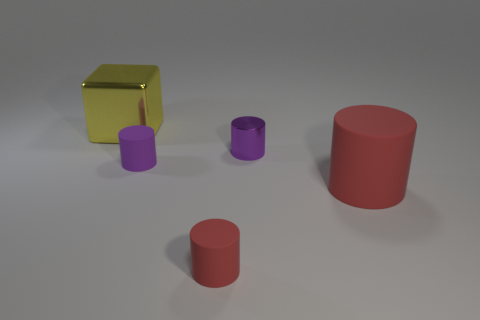Add 5 big things. How many objects exist? 10 Subtract all cylinders. How many objects are left? 1 Add 5 small metal things. How many small metal things are left? 6 Add 5 big red cylinders. How many big red cylinders exist? 6 Subtract 0 blue cubes. How many objects are left? 5 Subtract all small red shiny cylinders. Subtract all red things. How many objects are left? 3 